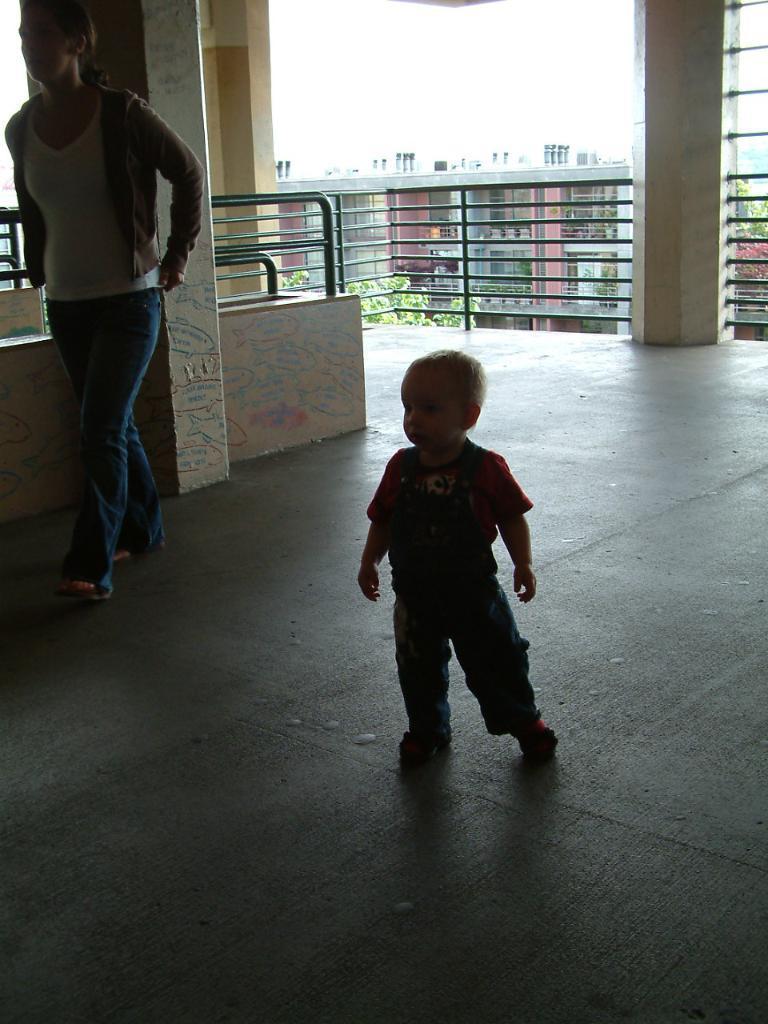Could you give a brief overview of what you see in this image? In this picture there is a woman and a boy are walking on the floor and we can see the wall and railings. In the background of the image we can see trees, building and sky. 